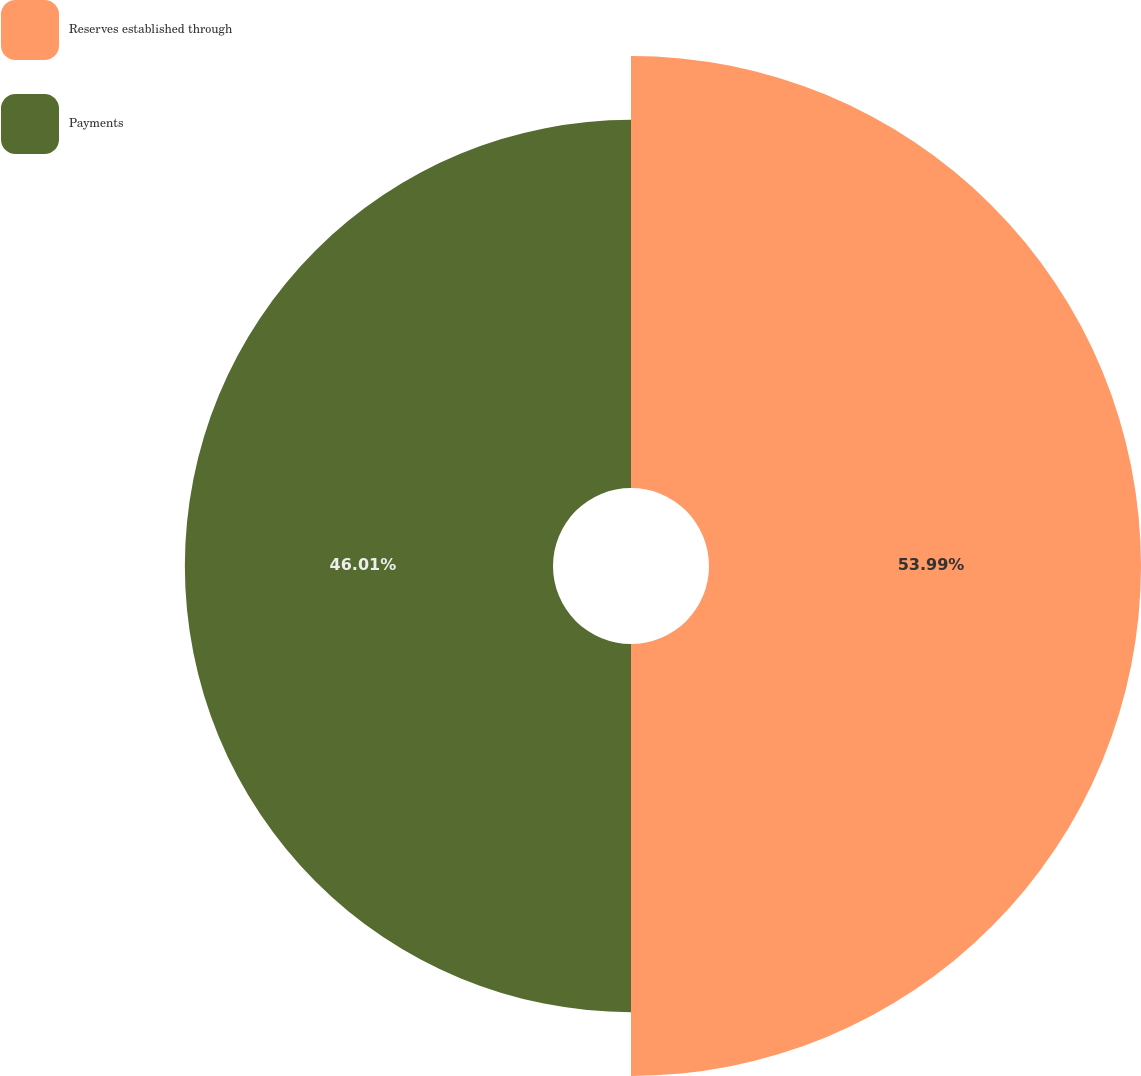Convert chart to OTSL. <chart><loc_0><loc_0><loc_500><loc_500><pie_chart><fcel>Reserves established through<fcel>Payments<nl><fcel>53.99%<fcel>46.01%<nl></chart> 